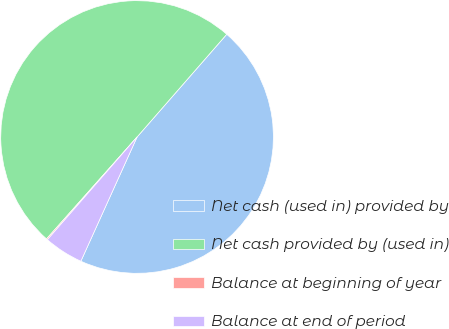Convert chart. <chart><loc_0><loc_0><loc_500><loc_500><pie_chart><fcel>Net cash (used in) provided by<fcel>Net cash provided by (used in)<fcel>Balance at beginning of year<fcel>Balance at end of period<nl><fcel>45.34%<fcel>49.86%<fcel>0.14%<fcel>4.66%<nl></chart> 